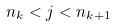Convert formula to latex. <formula><loc_0><loc_0><loc_500><loc_500>n _ { k } < j < n _ { k + 1 }</formula> 